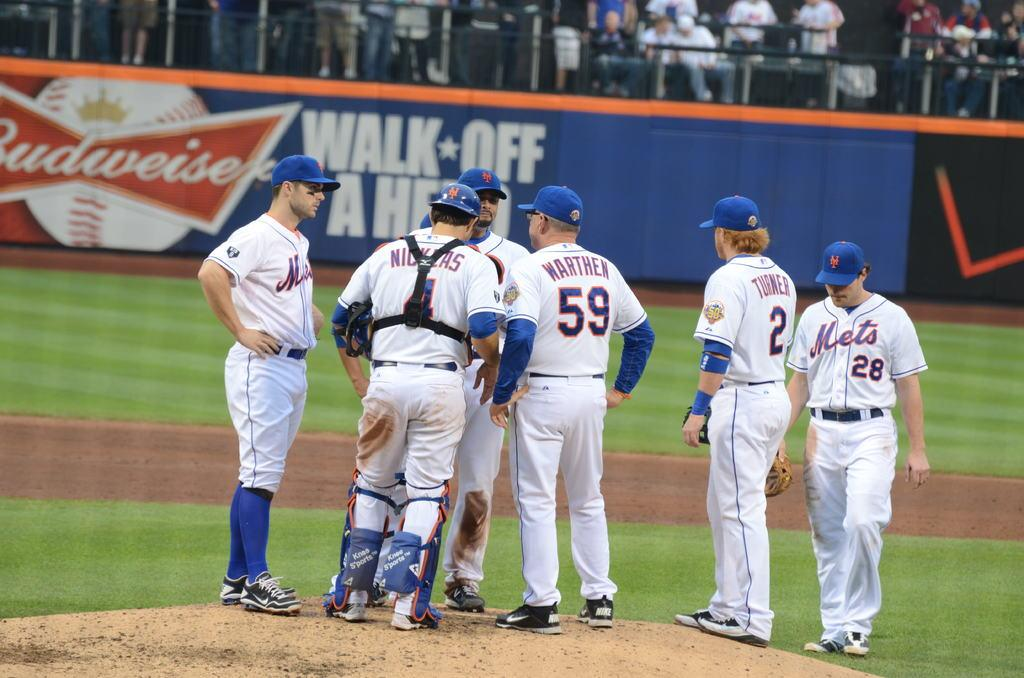<image>
Create a compact narrative representing the image presented. Sportsmen standing on a field with an advert for Budweiser in the background. 